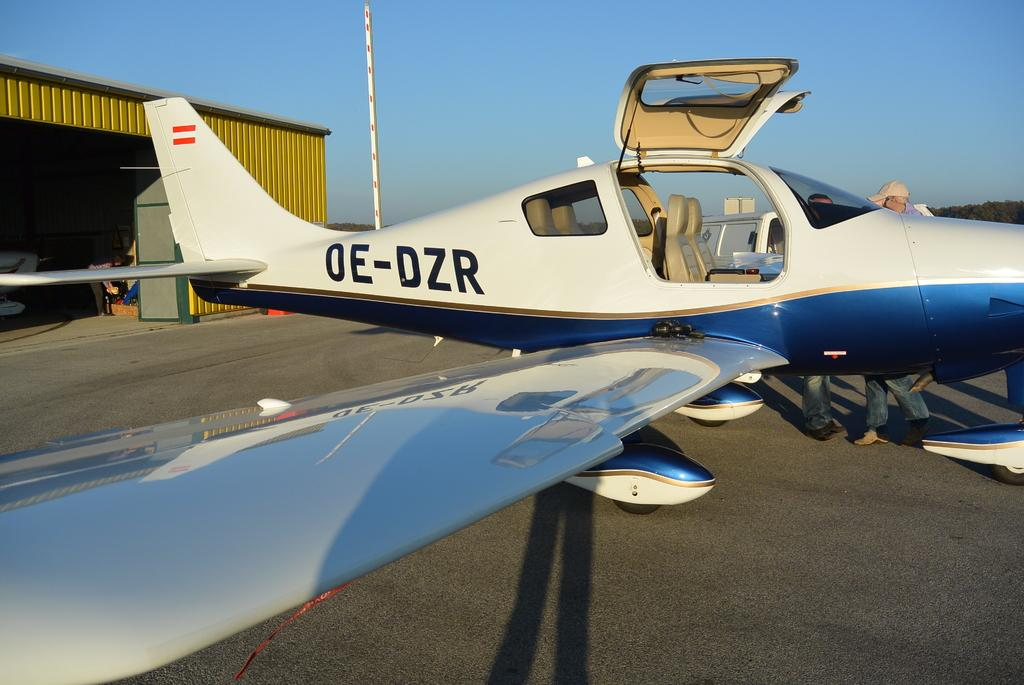<image>
Write a terse but informative summary of the picture. the letters DZR are on the side of a plane 